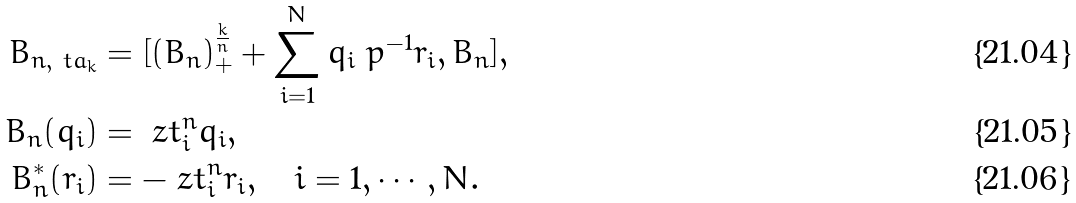Convert formula to latex. <formula><loc_0><loc_0><loc_500><loc_500>B _ { n , \ t a _ { k } } & = [ ( B _ { n } ) ^ { \frac { k } { n } } _ { + } + \sum _ { i = 1 } ^ { N } q _ { i } \ p ^ { - 1 } r _ { i } , B _ { n } ] , \\ B _ { n } ( q _ { i } ) & = \ z t _ { i } ^ { n } q _ { i } , \\ B _ { n } ^ { * } ( r _ { i } ) & = - \ z t _ { i } ^ { n } r _ { i } , \quad i = 1 , \cdots , N .</formula> 